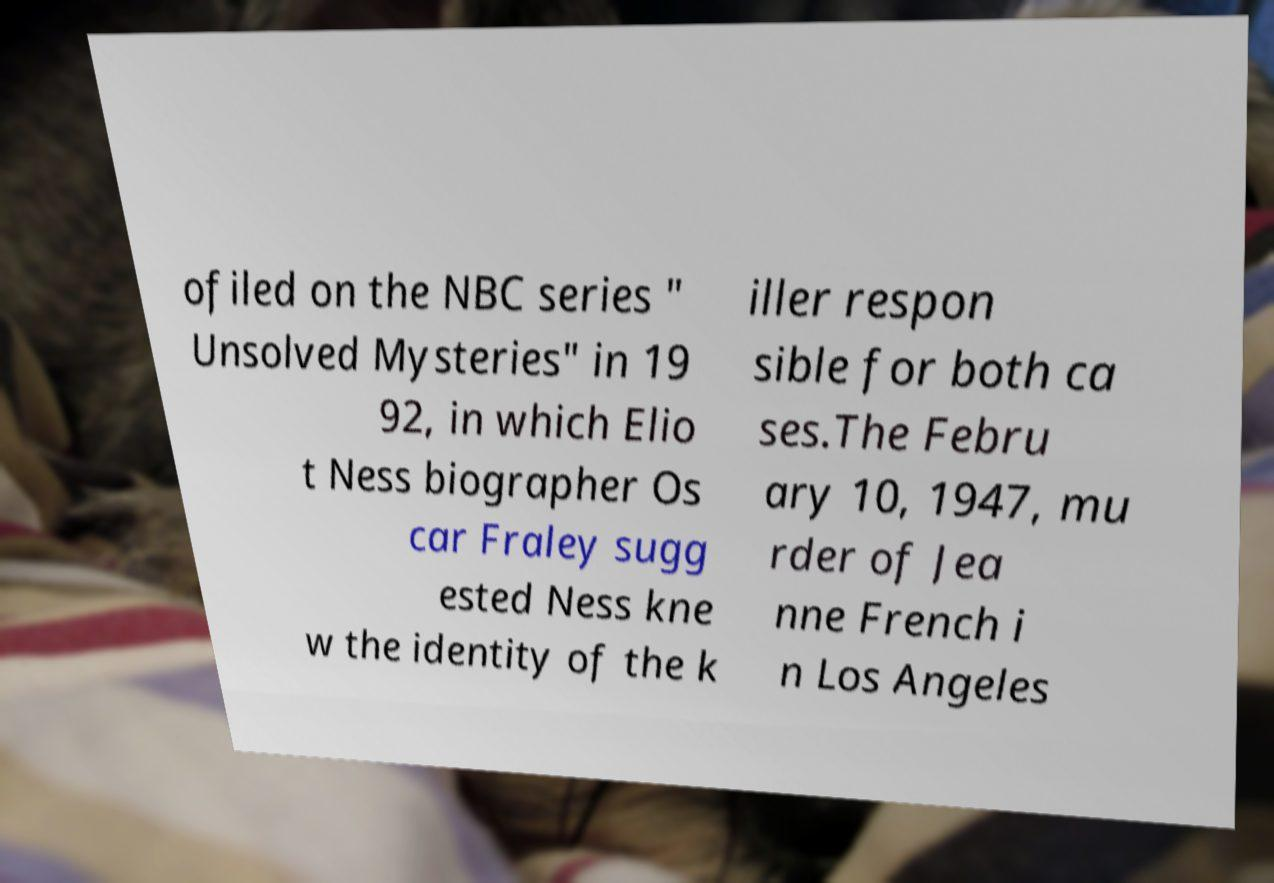Please read and relay the text visible in this image. What does it say? ofiled on the NBC series " Unsolved Mysteries" in 19 92, in which Elio t Ness biographer Os car Fraley sugg ested Ness kne w the identity of the k iller respon sible for both ca ses.The Febru ary 10, 1947, mu rder of Jea nne French i n Los Angeles 